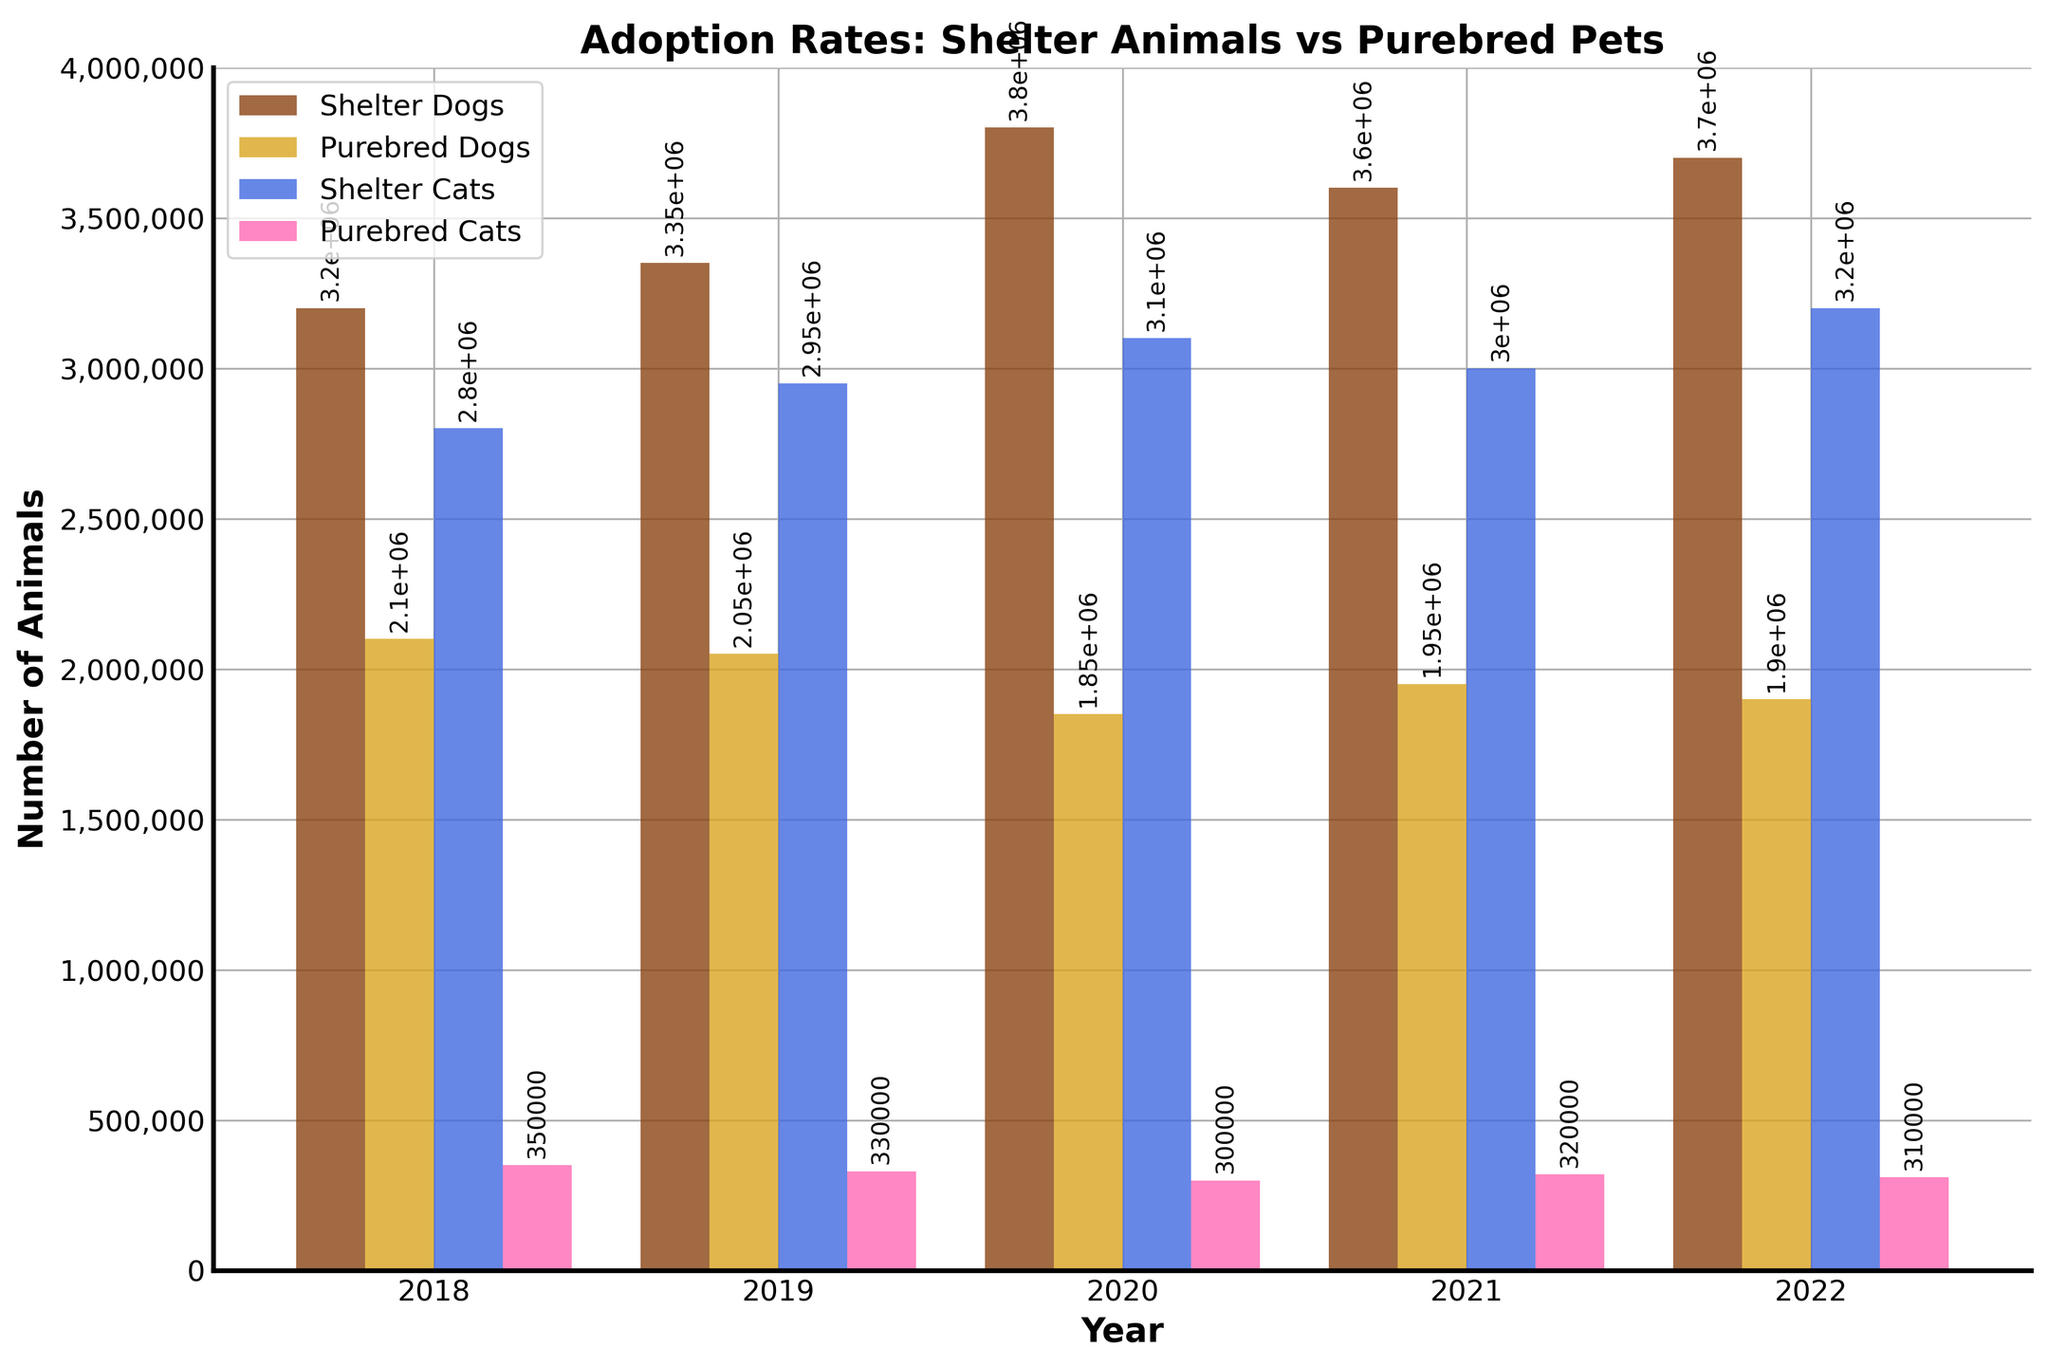Which category had the highest adoption rate in 2020? The highest bar in 2020 represents shelter dogs, indicating that more shelter dogs were adopted than any other category in that year.
Answer: Shelter Dogs How did the adoption rate for shelter cats change from 2018 to 2022? In 2018, the adoption rate for shelter cats was 2,800,000. By 2022, this rate increased to 3,200,000, indicating a positive change. The difference shows that the adoption rate for shelter cats increased by 400,000 over these years.
Answer: Increased Which year saw the lowest purchase rate for purebred cats? The bar for purebred cats is shortest in 2020, indicating that 2020 had the lowest purchase rate for purebred cats at 300,000.
Answer: 2020 Did the adoption rate for shelter dogs increase or decrease from 2019 to 2020? In 2019, the adoption rate for shelter dogs was 3,350,000. In 2020, it increased to 3,800,000. This shows an increase in the adoption rate.
Answer: Increase Which had more purchases in 2021, purebred dogs or purebred cats? By comparing the height of their respective bars, we see that purebred dogs had more purchases (1,950,000) than purebred cats (320,000) in 2021.
Answer: Purebred Dogs What is the total number of shelter animals adopted in 2022? Add the number of shelter dogs (3,700,000) and shelter cats (3,200,000) adopted in 2022. This gives a total of 6,900,000.
Answer: 6,900,000 What was the trend for the purchase of purebred dogs from 2018 to 2022? The bars for purebred dogs show a decreasing trend from 2018 (2,100,000) to 2022 (1,900,000). This suggests that fewer purebred dogs were being purchased over the years.
Answer: Decreasing What was the difference between shelter dog adoptions and purebred dog purchases in 2020? In 2020, shelter dog adoptions were 3,800,000 and purebred dog purchases were 1,850,000. The difference is 3,800,000 - 1,850,000 = 1,950,000.
Answer: 1,950,000 